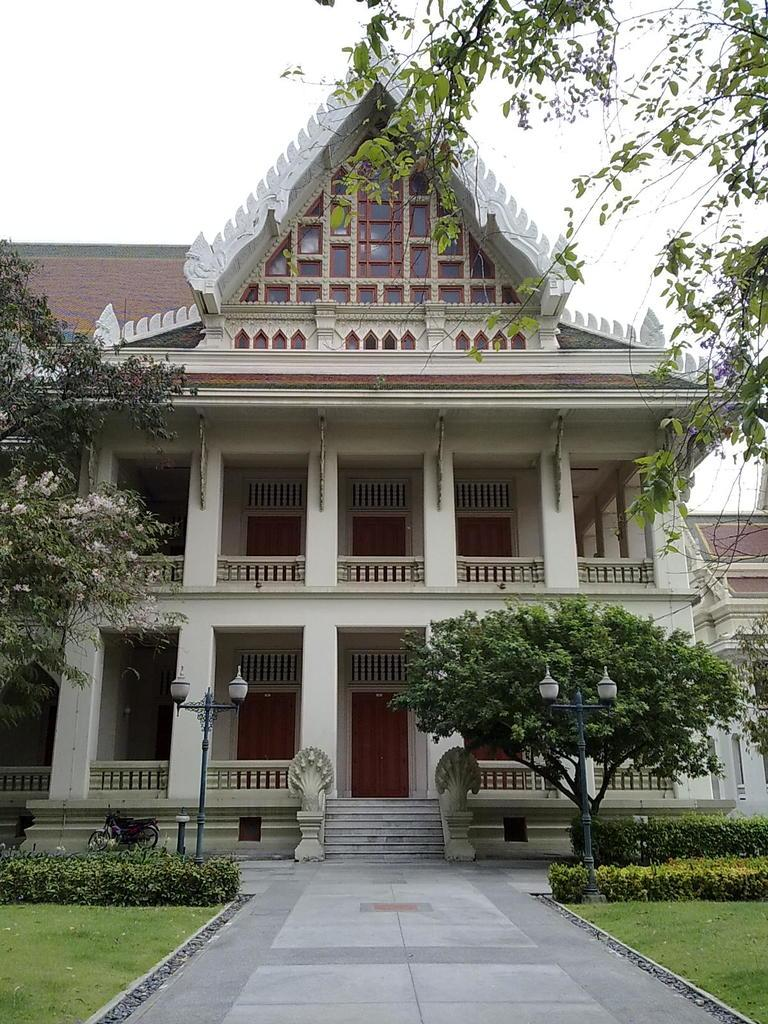What type of vegetation can be seen in the image? There is grass, plants, trees, and flowers in the image. What kind of surface is present for walking or traversing? There is a path in the image. What architectural features are visible in the background of the image? There are light poles, steps, a building, a house, and railings in the background of the image. What part of the natural environment is visible in the image? The sky is visible in the background of the image. What type of collar can be seen on the dog in the image? There are no dogs or collars present in the image. How does the grass affect the stomach of the person in the image? There is no person present in the image, and the grass does not have any direct effect on a person's stomach. 